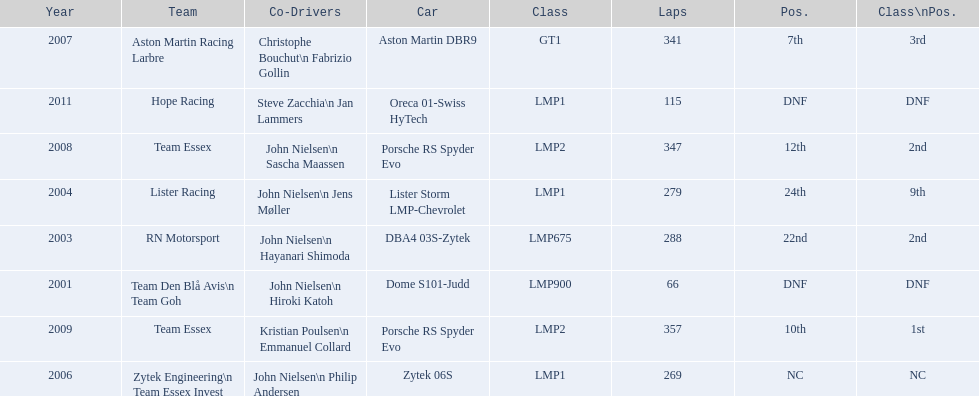Who was casper elgaard's co-driver the most often for the 24 hours of le mans? John Nielsen. 